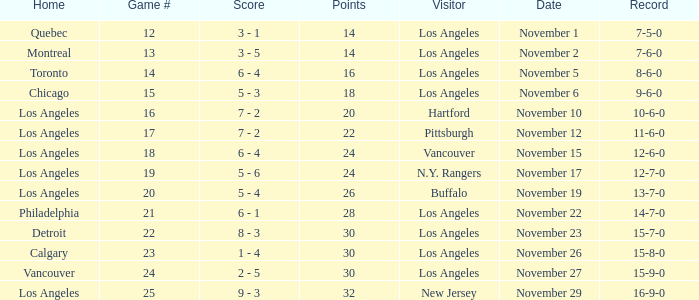Help me parse the entirety of this table. {'header': ['Home', 'Game #', 'Score', 'Points', 'Visitor', 'Date', 'Record'], 'rows': [['Quebec', '12', '3 - 1', '14', 'Los Angeles', 'November 1', '7-5-0'], ['Montreal', '13', '3 - 5', '14', 'Los Angeles', 'November 2', '7-6-0'], ['Toronto', '14', '6 - 4', '16', 'Los Angeles', 'November 5', '8-6-0'], ['Chicago', '15', '5 - 3', '18', 'Los Angeles', 'November 6', '9-6-0'], ['Los Angeles', '16', '7 - 2', '20', 'Hartford', 'November 10', '10-6-0'], ['Los Angeles', '17', '7 - 2', '22', 'Pittsburgh', 'November 12', '11-6-0'], ['Los Angeles', '18', '6 - 4', '24', 'Vancouver', 'November 15', '12-6-0'], ['Los Angeles', '19', '5 - 6', '24', 'N.Y. Rangers', 'November 17', '12-7-0'], ['Los Angeles', '20', '5 - 4', '26', 'Buffalo', 'November 19', '13-7-0'], ['Philadelphia', '21', '6 - 1', '28', 'Los Angeles', 'November 22', '14-7-0'], ['Detroit', '22', '8 - 3', '30', 'Los Angeles', 'November 23', '15-7-0'], ['Calgary', '23', '1 - 4', '30', 'Los Angeles', 'November 26', '15-8-0'], ['Vancouver', '24', '2 - 5', '30', 'Los Angeles', 'November 27', '15-9-0'], ['Los Angeles', '25', '9 - 3', '32', 'New Jersey', 'November 29', '16-9-0']]} What is the record of the game on November 22? 14-7-0. 